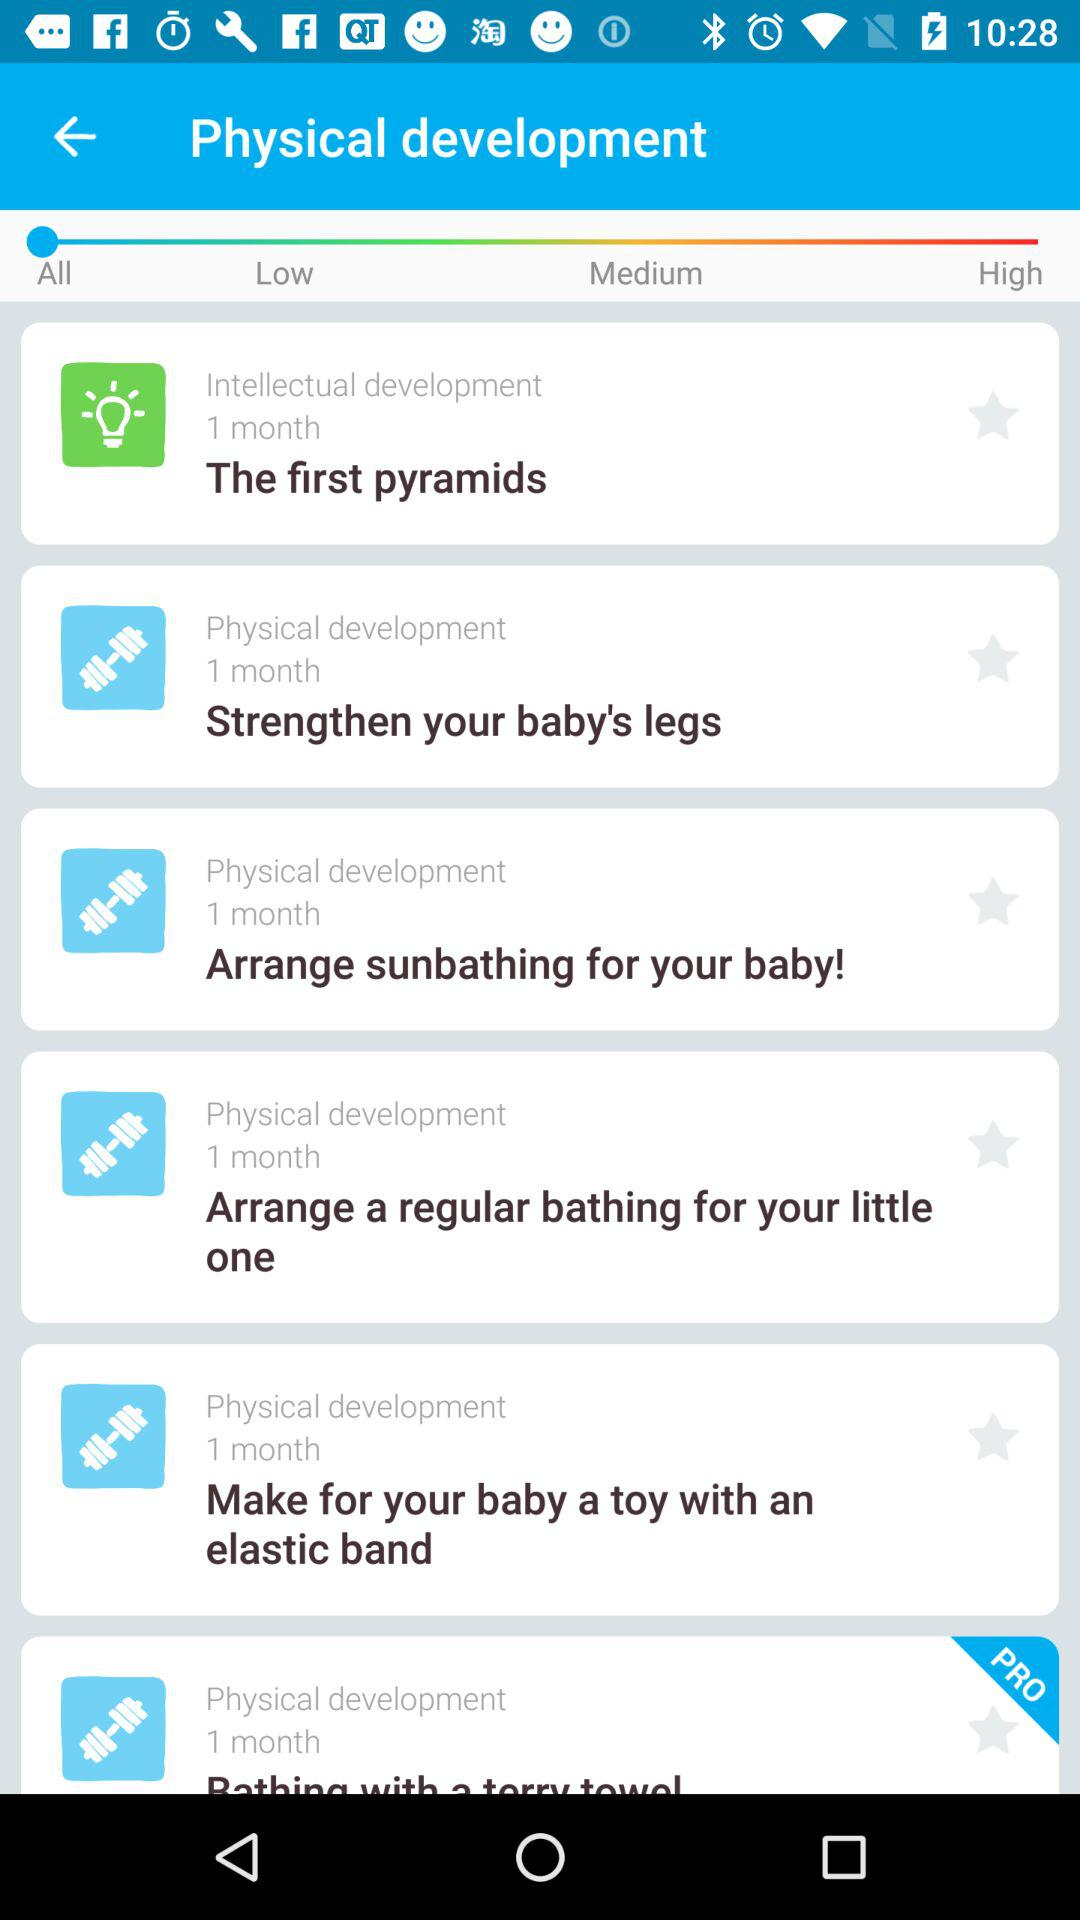How many of the tasks are related to 'Physical development'?
Answer the question using a single word or phrase. 5 